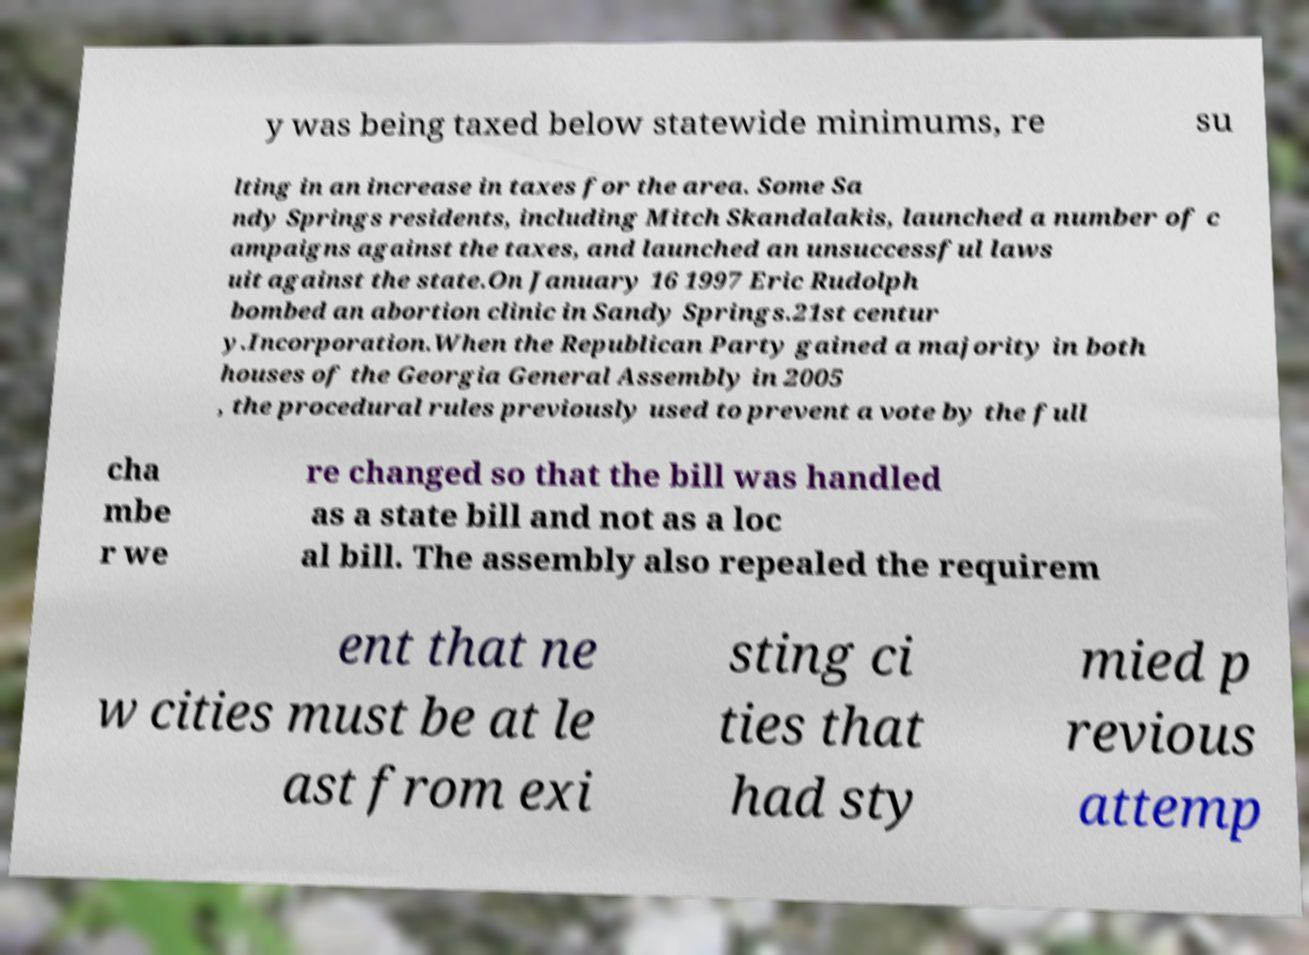Please read and relay the text visible in this image. What does it say? y was being taxed below statewide minimums, re su lting in an increase in taxes for the area. Some Sa ndy Springs residents, including Mitch Skandalakis, launched a number of c ampaigns against the taxes, and launched an unsuccessful laws uit against the state.On January 16 1997 Eric Rudolph bombed an abortion clinic in Sandy Springs.21st centur y.Incorporation.When the Republican Party gained a majority in both houses of the Georgia General Assembly in 2005 , the procedural rules previously used to prevent a vote by the full cha mbe r we re changed so that the bill was handled as a state bill and not as a loc al bill. The assembly also repealed the requirem ent that ne w cities must be at le ast from exi sting ci ties that had sty mied p revious attemp 